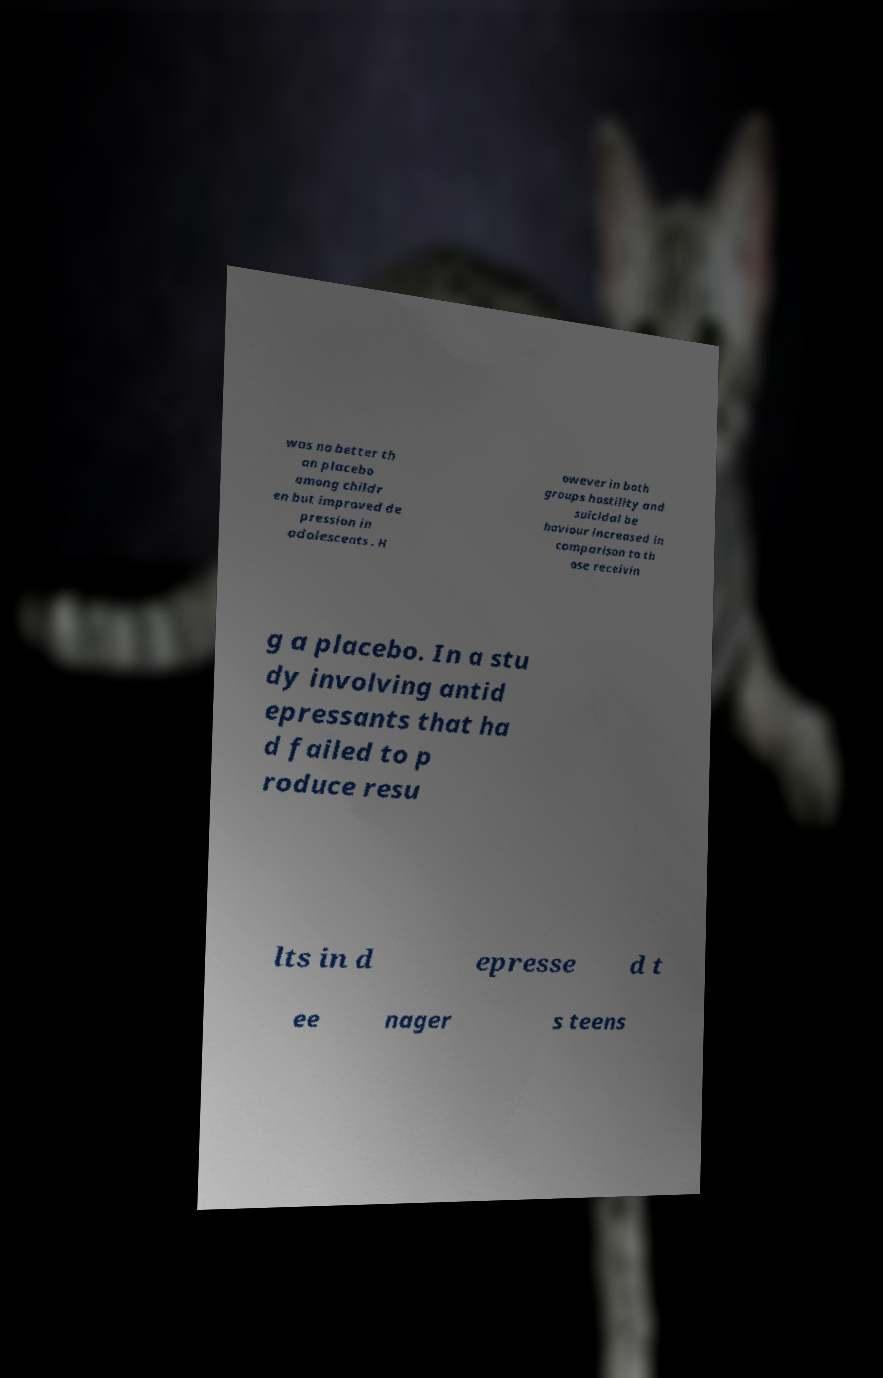Can you read and provide the text displayed in the image?This photo seems to have some interesting text. Can you extract and type it out for me? was no better th an placebo among childr en but improved de pression in adolescents . H owever in both groups hostility and suicidal be haviour increased in comparison to th ose receivin g a placebo. In a stu dy involving antid epressants that ha d failed to p roduce resu lts in d epresse d t ee nager s teens 